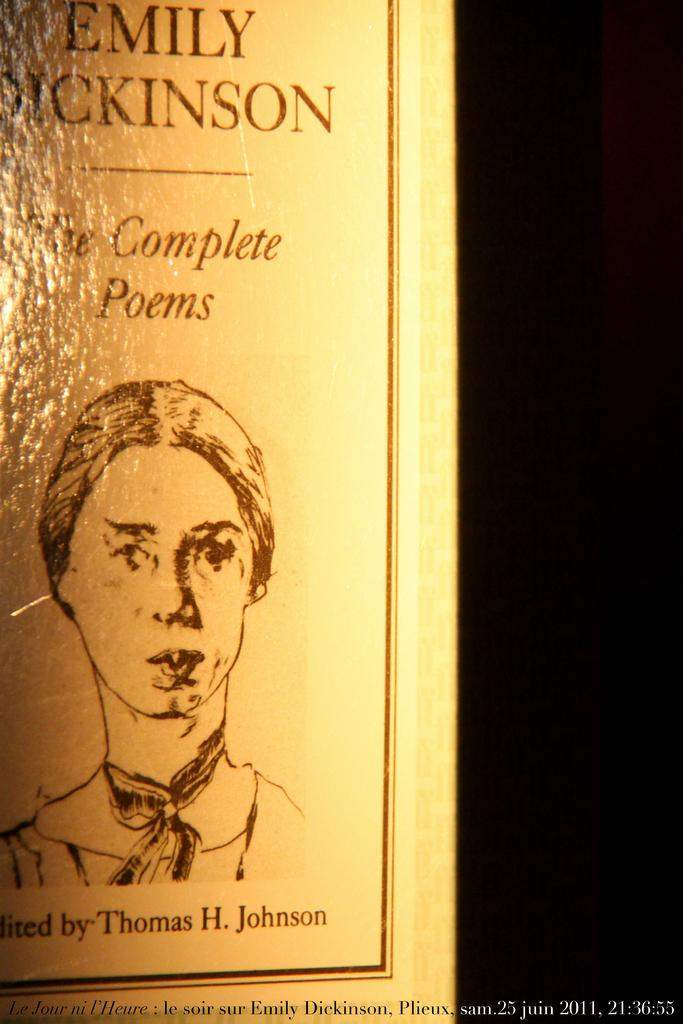What is the main subject in the center of the image? There is a poster in the center of the image. What is depicted on the poster? The poster features a person. Are there any words on the poster? Yes, there is text on the poster. Can you read any text in the image besides the poster? Yes, there is text visible at the bottom of the image. How does the person on the poster express their hate towards the sticks in the image? There is no mention of hate or sticks in the image; the poster features a person and text. 